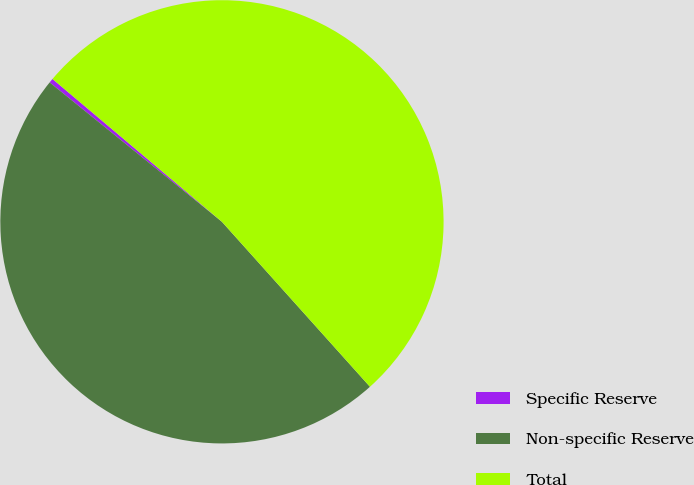<chart> <loc_0><loc_0><loc_500><loc_500><pie_chart><fcel>Specific Reserve<fcel>Non-specific Reserve<fcel>Total<nl><fcel>0.32%<fcel>47.47%<fcel>52.22%<nl></chart> 